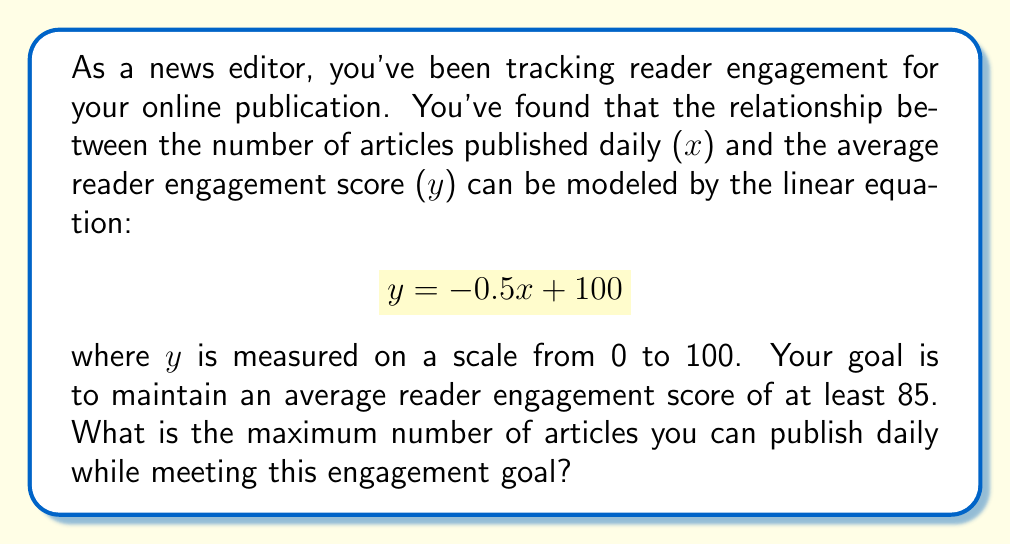Can you solve this math problem? To solve this problem, we need to follow these steps:

1. Understand the given equation:
   $$ y = -0.5x + 100 $$
   where y is the reader engagement score and x is the number of articles published daily.

2. Set up an inequality based on the engagement goal:
   We want the engagement score (y) to be at least 85.
   $$ y \geq 85 $$

3. Substitute the equation into the inequality:
   $$ -0.5x + 100 \geq 85 $$

4. Solve the inequality for x:
   $$ -0.5x \geq 85 - 100 $$
   $$ -0.5x \geq -15 $$
   $$ x \leq 30 $$

5. Interpret the result:
   Since x represents the number of articles and must be a whole number, we need to round down to the nearest integer.
Answer: The maximum number of articles that can be published daily while maintaining an average reader engagement score of at least 85 is 30. 